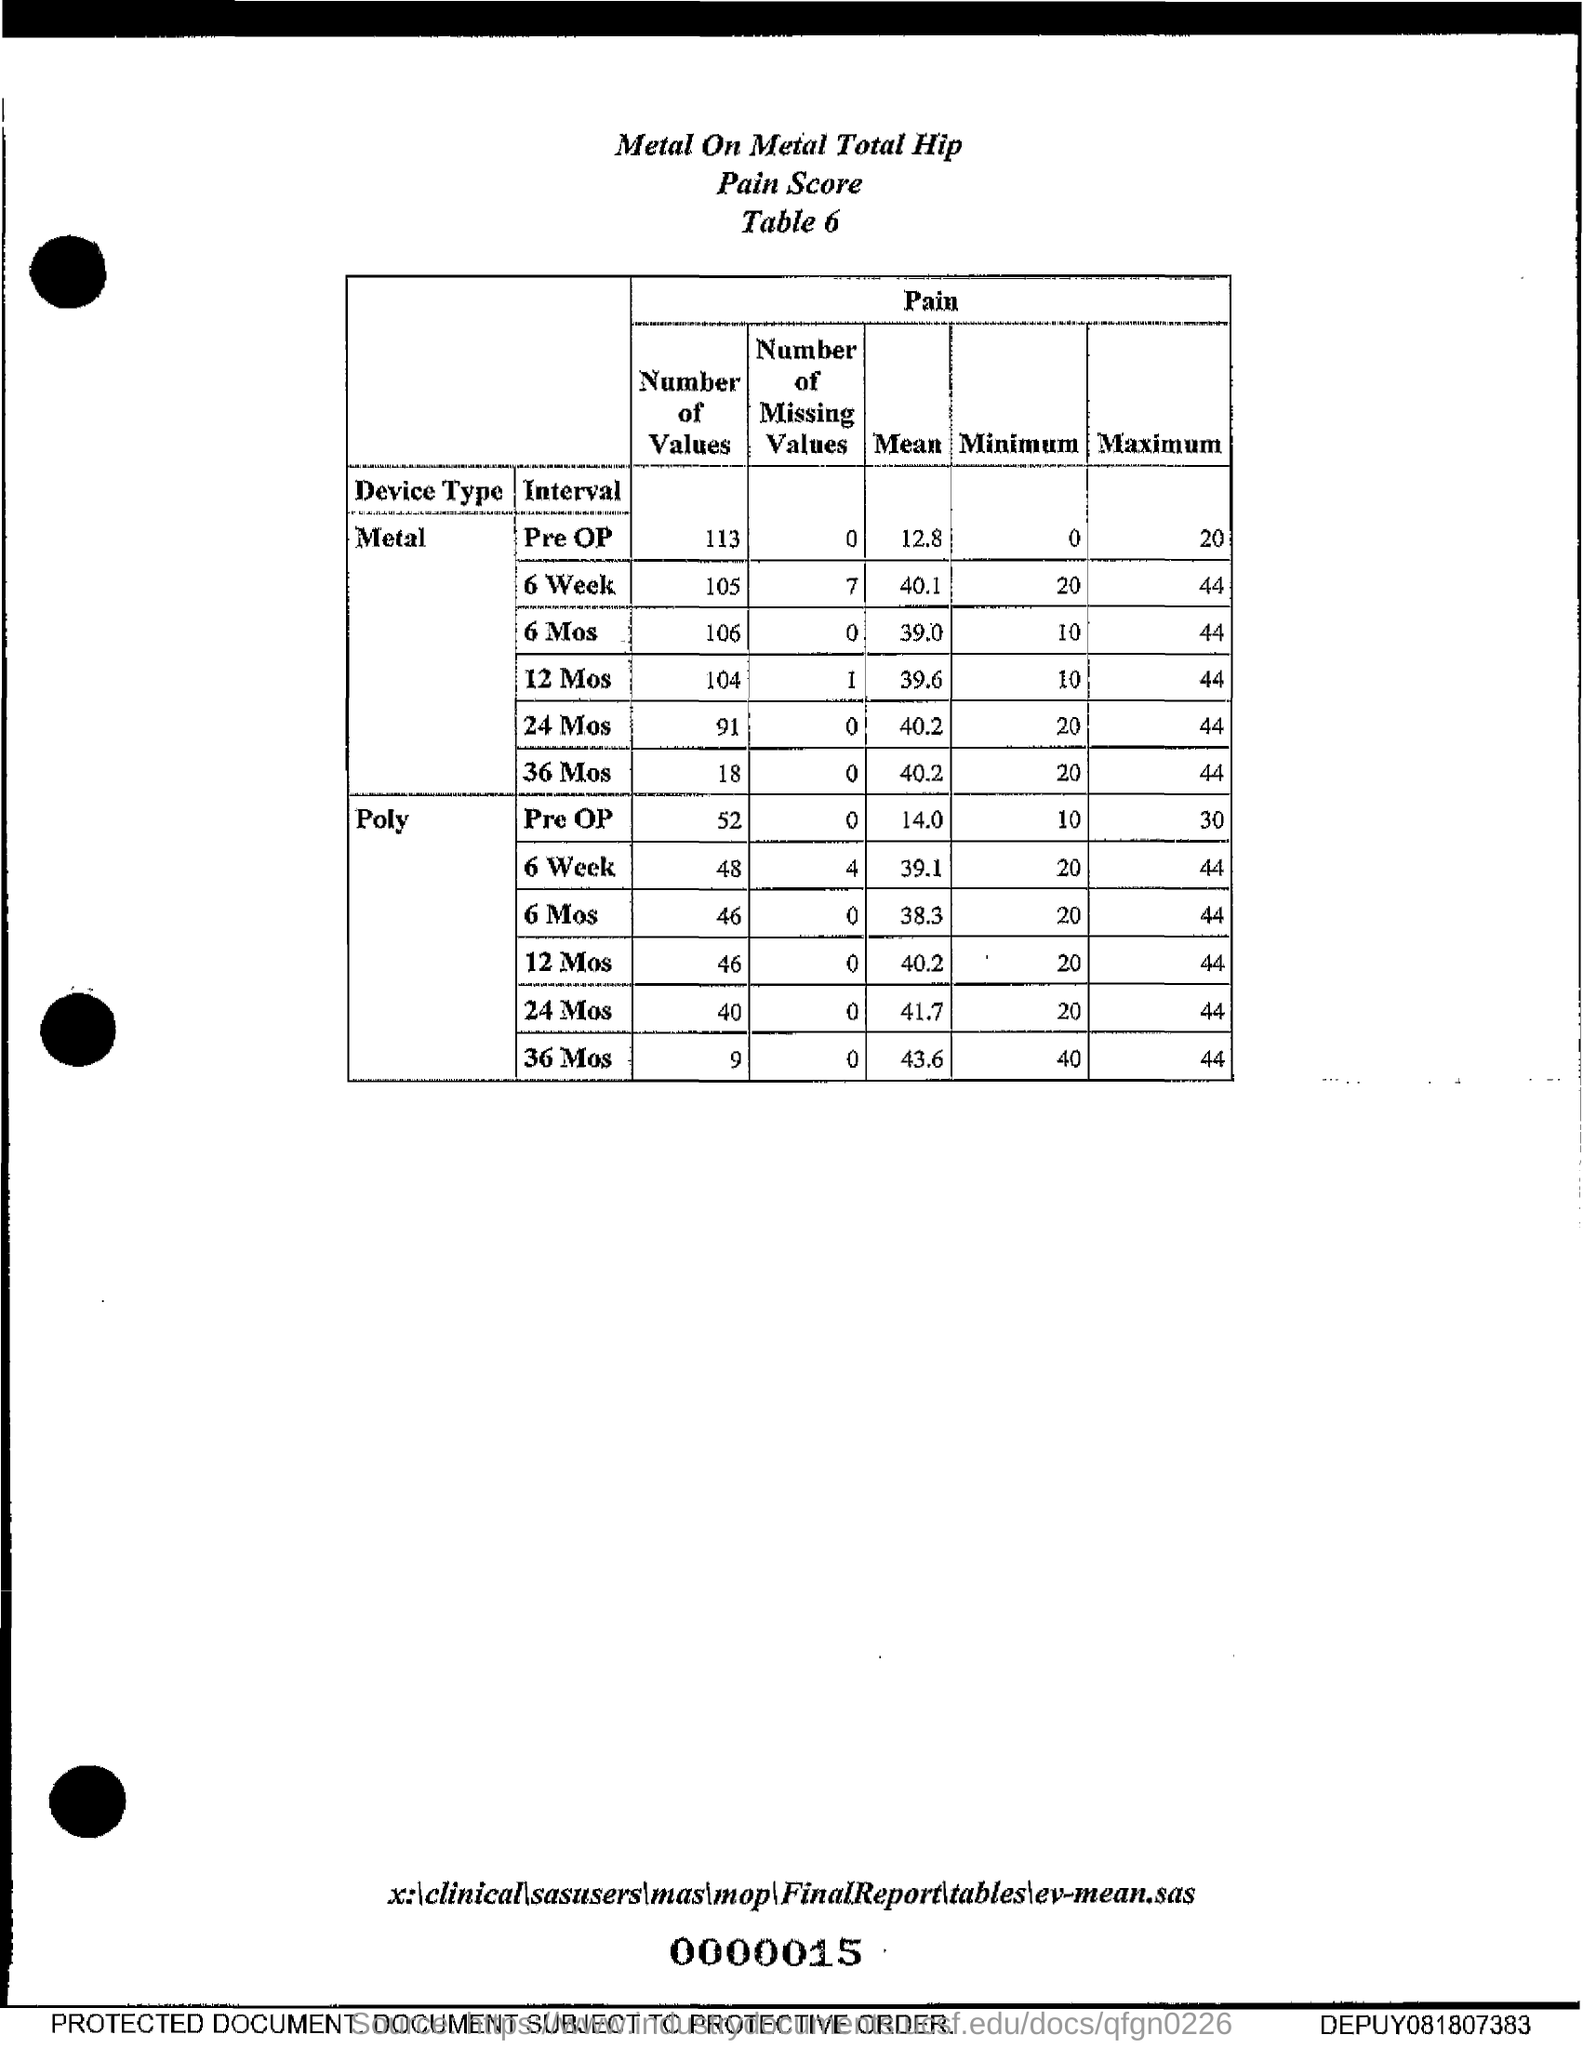What is the mean for metal Pre Op?
Keep it short and to the point. 12.8. What is the mean for metal 6 Week?
Keep it short and to the point. 40.1. What is the mean for metal 6 Mos?
Your answer should be compact. 39.0. What is the mean for metal 12 Mos?
Provide a short and direct response. 39.6. What is the mean for metal 24 Mos?
Provide a succinct answer. 40.2. What is the mean for metal 36 Mos?
Your answer should be very brief. 40.2. What is the mean for Poly for Pre OP?
Your answer should be compact. 14.0. What is the mean for Poly for 6 Week?
Keep it short and to the point. 39.1. What is the mean for Poly for 6 Mos?
Your response must be concise. 38.3. What is the mean for Poly for 12 Mos?
Your answer should be compact. 40.2. 